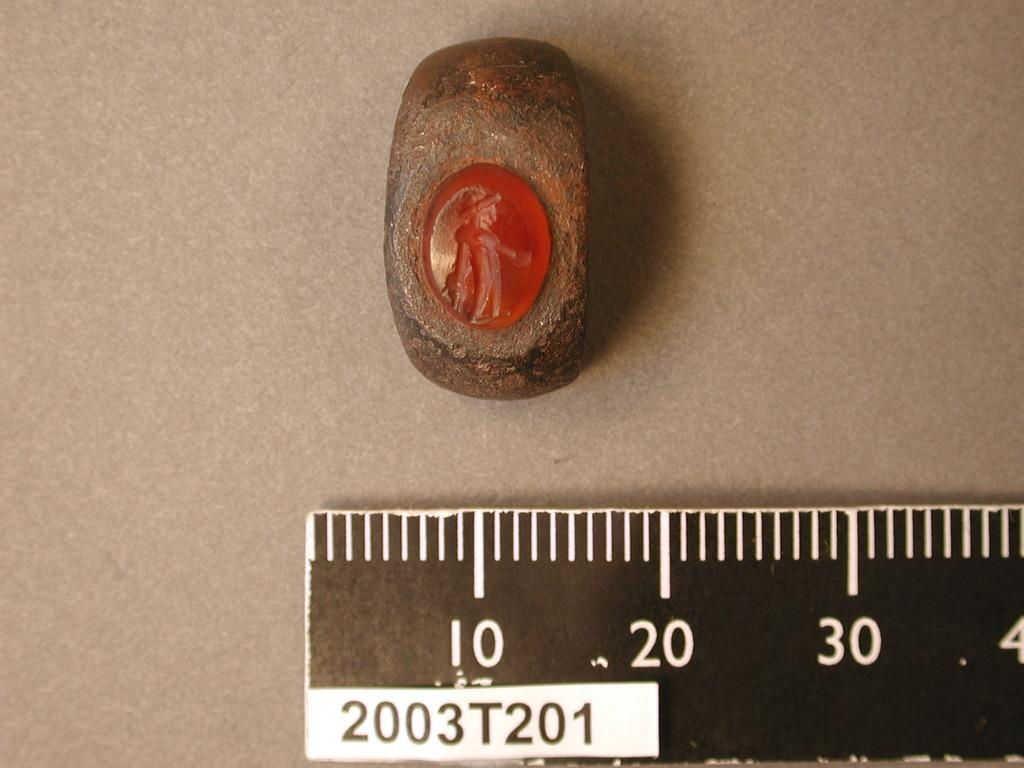Provide a one-sentence caption for the provided image. A rock that is 20 centimeters that has a carving of a person on it. 